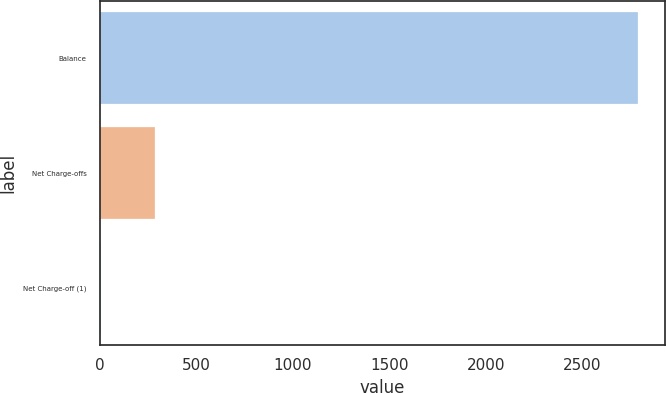Convert chart to OTSL. <chart><loc_0><loc_0><loc_500><loc_500><bar_chart><fcel>Balance<fcel>Net Charge-offs<fcel>Net Charge-off (1)<nl><fcel>2786<fcel>283.96<fcel>5.96<nl></chart> 